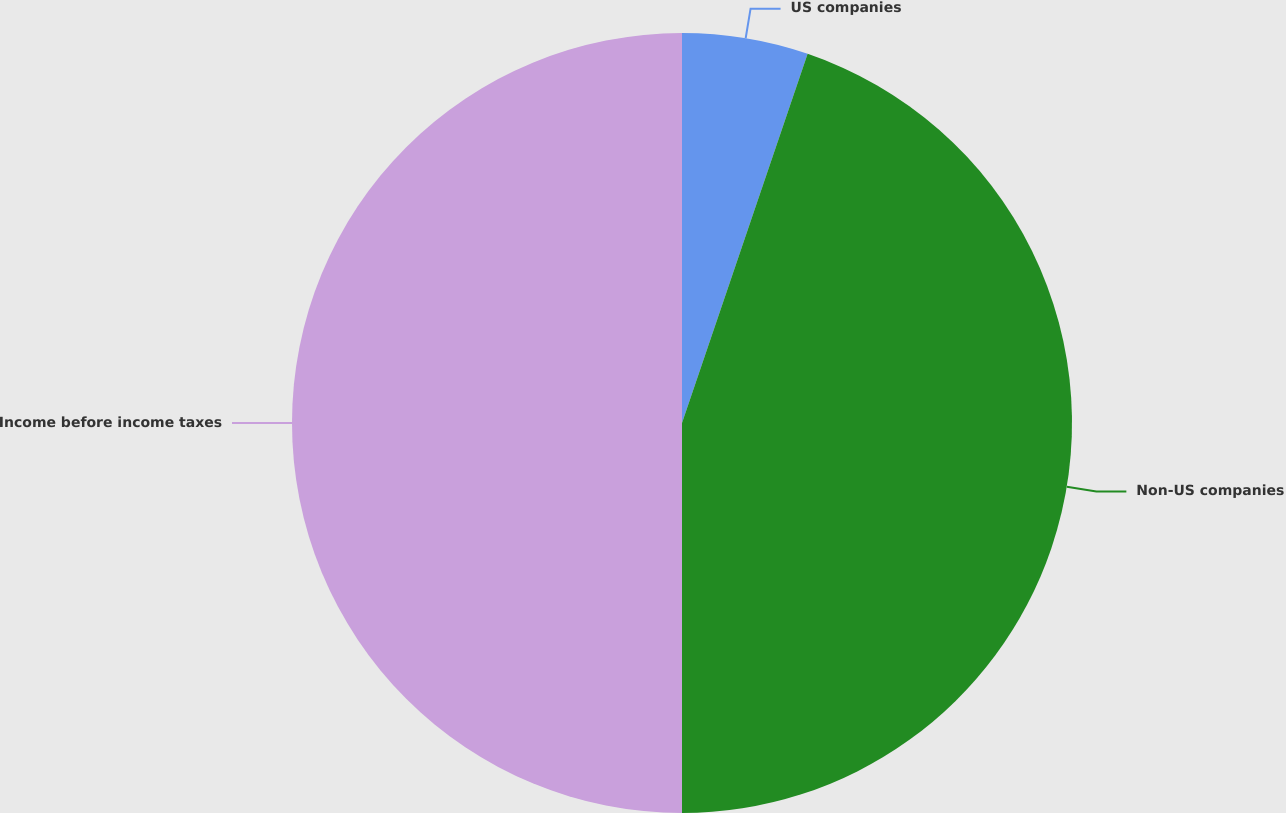<chart> <loc_0><loc_0><loc_500><loc_500><pie_chart><fcel>US companies<fcel>Non-US companies<fcel>Income before income taxes<nl><fcel>5.22%<fcel>44.78%<fcel>50.0%<nl></chart> 